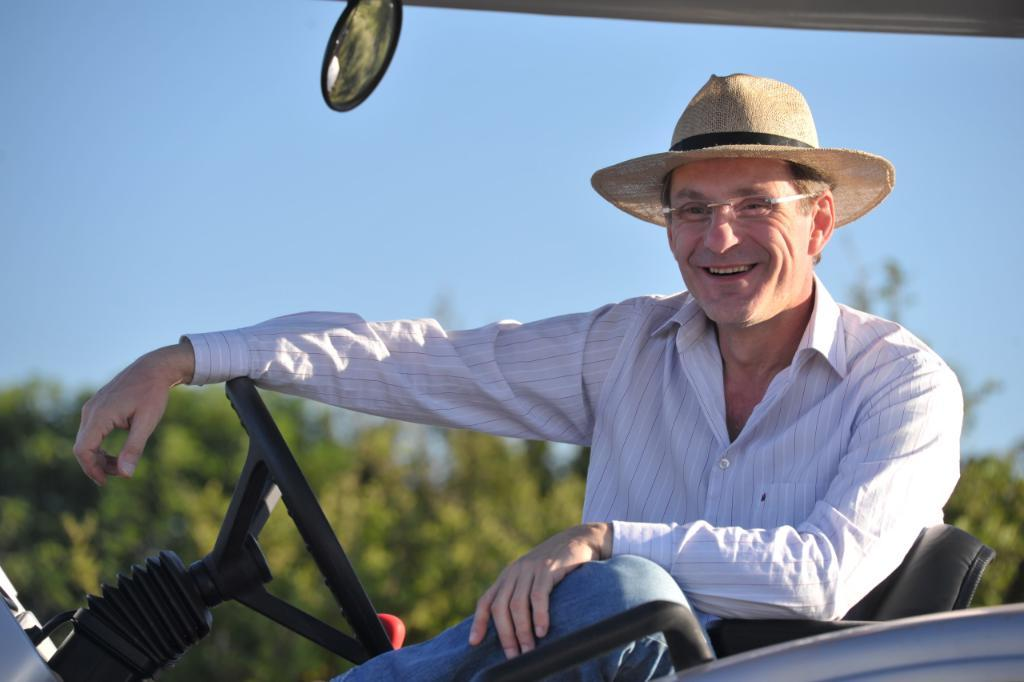What is the main subject of the image? There is a person in the image. What accessories is the person wearing? The person is wearing specs and a hat. What is the person doing in the image? The person is sitting on a vehicle. What can be seen in the background of the image? There is sky and trees visible in the background, and the background is blurry. What type of advertisement can be seen on the seat in the image? There is no advertisement present on the seat in the image; it is a person sitting on a vehicle. What camping equipment is visible in the image? There is no camping equipment visible in the image; it features a person sitting on a vehicle with a blurry background. 